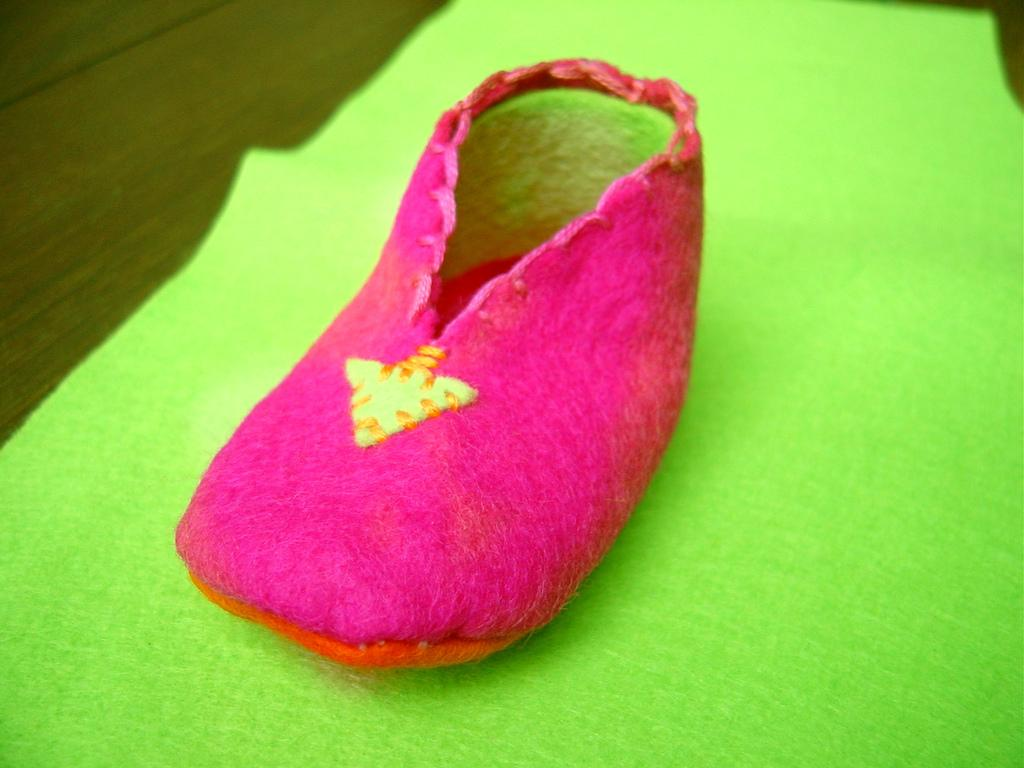What color is the object in the image? The object in the image is pink. What type of object is it? The object appears to be a shoe. Where is the shoe placed? The shoe is placed on a sheet. What material can be seen at the top of the image? There is a wooden plank at the top of the image. What type of poison is being stored in the cup in the image? There is no cup or poison present in the image. What station is visible in the background of the image? There is no station visible in the image; it only contains a pink shoe, a sheet, and a wooden plank. 